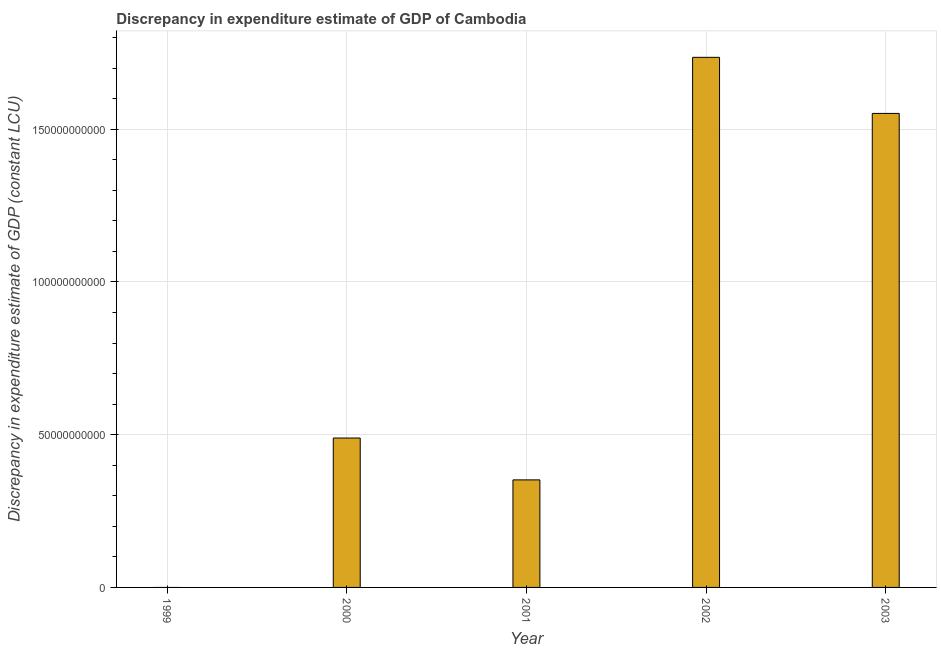Does the graph contain grids?
Provide a succinct answer. Yes. What is the title of the graph?
Make the answer very short. Discrepancy in expenditure estimate of GDP of Cambodia. What is the label or title of the Y-axis?
Keep it short and to the point. Discrepancy in expenditure estimate of GDP (constant LCU). What is the discrepancy in expenditure estimate of gdp in 2000?
Offer a very short reply. 4.89e+1. Across all years, what is the maximum discrepancy in expenditure estimate of gdp?
Your answer should be compact. 1.74e+11. Across all years, what is the minimum discrepancy in expenditure estimate of gdp?
Provide a short and direct response. 0. What is the sum of the discrepancy in expenditure estimate of gdp?
Ensure brevity in your answer.  4.13e+11. What is the difference between the discrepancy in expenditure estimate of gdp in 2002 and 2003?
Provide a short and direct response. 1.84e+1. What is the average discrepancy in expenditure estimate of gdp per year?
Offer a very short reply. 8.26e+1. What is the median discrepancy in expenditure estimate of gdp?
Provide a succinct answer. 4.89e+1. What is the ratio of the discrepancy in expenditure estimate of gdp in 2000 to that in 2001?
Keep it short and to the point. 1.39. Is the difference between the discrepancy in expenditure estimate of gdp in 2002 and 2003 greater than the difference between any two years?
Provide a short and direct response. No. What is the difference between the highest and the second highest discrepancy in expenditure estimate of gdp?
Provide a succinct answer. 1.84e+1. What is the difference between the highest and the lowest discrepancy in expenditure estimate of gdp?
Make the answer very short. 1.74e+11. How many bars are there?
Give a very brief answer. 4. How many years are there in the graph?
Provide a succinct answer. 5. Are the values on the major ticks of Y-axis written in scientific E-notation?
Offer a terse response. No. What is the Discrepancy in expenditure estimate of GDP (constant LCU) in 2000?
Give a very brief answer. 4.89e+1. What is the Discrepancy in expenditure estimate of GDP (constant LCU) of 2001?
Offer a terse response. 3.52e+1. What is the Discrepancy in expenditure estimate of GDP (constant LCU) of 2002?
Offer a terse response. 1.74e+11. What is the Discrepancy in expenditure estimate of GDP (constant LCU) of 2003?
Provide a short and direct response. 1.55e+11. What is the difference between the Discrepancy in expenditure estimate of GDP (constant LCU) in 2000 and 2001?
Your answer should be compact. 1.37e+1. What is the difference between the Discrepancy in expenditure estimate of GDP (constant LCU) in 2000 and 2002?
Provide a succinct answer. -1.25e+11. What is the difference between the Discrepancy in expenditure estimate of GDP (constant LCU) in 2000 and 2003?
Ensure brevity in your answer.  -1.06e+11. What is the difference between the Discrepancy in expenditure estimate of GDP (constant LCU) in 2001 and 2002?
Your answer should be compact. -1.38e+11. What is the difference between the Discrepancy in expenditure estimate of GDP (constant LCU) in 2001 and 2003?
Your answer should be compact. -1.20e+11. What is the difference between the Discrepancy in expenditure estimate of GDP (constant LCU) in 2002 and 2003?
Offer a terse response. 1.84e+1. What is the ratio of the Discrepancy in expenditure estimate of GDP (constant LCU) in 2000 to that in 2001?
Offer a very short reply. 1.39. What is the ratio of the Discrepancy in expenditure estimate of GDP (constant LCU) in 2000 to that in 2002?
Your answer should be compact. 0.28. What is the ratio of the Discrepancy in expenditure estimate of GDP (constant LCU) in 2000 to that in 2003?
Keep it short and to the point. 0.32. What is the ratio of the Discrepancy in expenditure estimate of GDP (constant LCU) in 2001 to that in 2002?
Provide a short and direct response. 0.2. What is the ratio of the Discrepancy in expenditure estimate of GDP (constant LCU) in 2001 to that in 2003?
Keep it short and to the point. 0.23. What is the ratio of the Discrepancy in expenditure estimate of GDP (constant LCU) in 2002 to that in 2003?
Provide a succinct answer. 1.12. 